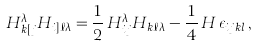Convert formula to latex. <formula><loc_0><loc_0><loc_500><loc_500>H ^ { \lambda } _ { k [ j } H _ { i ] \ell \lambda } = { \frac { 1 } { 2 } } \, H ^ { \lambda } _ { i j } H _ { k \ell \lambda } - { \frac { 1 } { 4 } } \, H \, \epsilon _ { i j k l } \, ,</formula> 